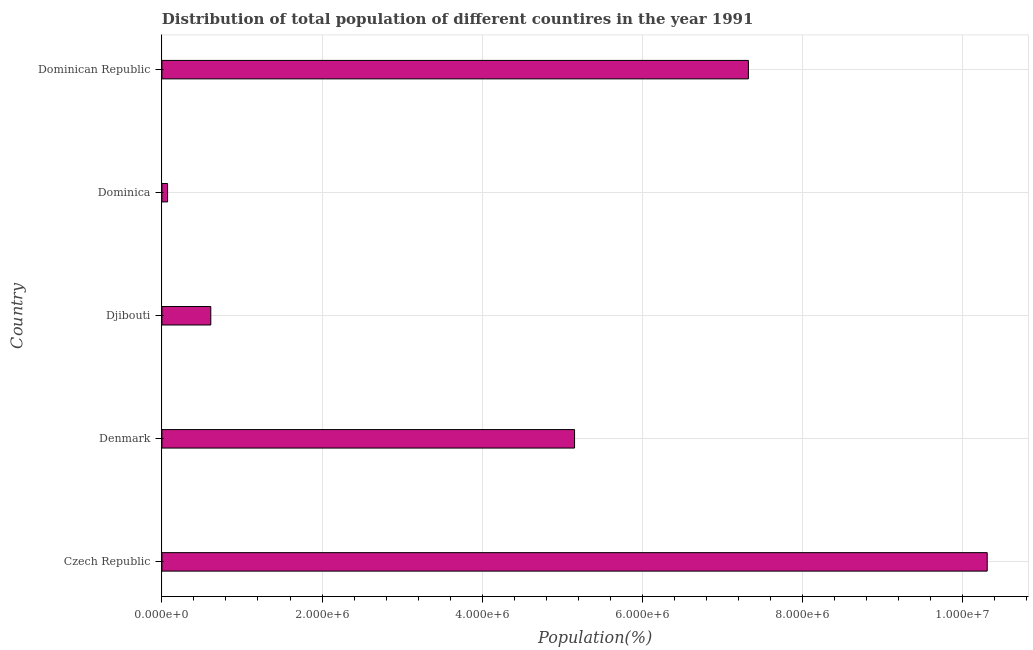Does the graph contain any zero values?
Your answer should be very brief. No. Does the graph contain grids?
Provide a short and direct response. Yes. What is the title of the graph?
Your answer should be very brief. Distribution of total population of different countires in the year 1991. What is the label or title of the X-axis?
Provide a succinct answer. Population(%). What is the population in Dominica?
Give a very brief answer. 7.08e+04. Across all countries, what is the maximum population?
Keep it short and to the point. 1.03e+07. Across all countries, what is the minimum population?
Your response must be concise. 7.08e+04. In which country was the population maximum?
Your answer should be compact. Czech Republic. In which country was the population minimum?
Provide a short and direct response. Dominica. What is the sum of the population?
Offer a terse response. 2.35e+07. What is the difference between the population in Denmark and Dominica?
Keep it short and to the point. 5.08e+06. What is the average population per country?
Ensure brevity in your answer.  4.69e+06. What is the median population?
Keep it short and to the point. 5.15e+06. In how many countries, is the population greater than 400000 %?
Your answer should be compact. 4. What is the ratio of the population in Czech Republic to that in Dominican Republic?
Your answer should be compact. 1.41. Is the population in Djibouti less than that in Dominican Republic?
Ensure brevity in your answer.  Yes. Is the difference between the population in Denmark and Dominican Republic greater than the difference between any two countries?
Offer a very short reply. No. What is the difference between the highest and the second highest population?
Keep it short and to the point. 2.98e+06. Is the sum of the population in Czech Republic and Denmark greater than the maximum population across all countries?
Keep it short and to the point. Yes. What is the difference between the highest and the lowest population?
Your answer should be compact. 1.02e+07. Are all the bars in the graph horizontal?
Your answer should be compact. Yes. What is the difference between two consecutive major ticks on the X-axis?
Your answer should be compact. 2.00e+06. Are the values on the major ticks of X-axis written in scientific E-notation?
Your response must be concise. Yes. What is the Population(%) in Czech Republic?
Your answer should be very brief. 1.03e+07. What is the Population(%) in Denmark?
Keep it short and to the point. 5.15e+06. What is the Population(%) in Djibouti?
Ensure brevity in your answer.  6.11e+05. What is the Population(%) in Dominica?
Offer a terse response. 7.08e+04. What is the Population(%) in Dominican Republic?
Give a very brief answer. 7.33e+06. What is the difference between the Population(%) in Czech Republic and Denmark?
Give a very brief answer. 5.15e+06. What is the difference between the Population(%) in Czech Republic and Djibouti?
Make the answer very short. 9.70e+06. What is the difference between the Population(%) in Czech Republic and Dominica?
Ensure brevity in your answer.  1.02e+07. What is the difference between the Population(%) in Czech Republic and Dominican Republic?
Provide a succinct answer. 2.98e+06. What is the difference between the Population(%) in Denmark and Djibouti?
Offer a terse response. 4.54e+06. What is the difference between the Population(%) in Denmark and Dominica?
Your response must be concise. 5.08e+06. What is the difference between the Population(%) in Denmark and Dominican Republic?
Provide a short and direct response. -2.17e+06. What is the difference between the Population(%) in Djibouti and Dominica?
Offer a terse response. 5.40e+05. What is the difference between the Population(%) in Djibouti and Dominican Republic?
Provide a succinct answer. -6.71e+06. What is the difference between the Population(%) in Dominica and Dominican Republic?
Provide a short and direct response. -7.25e+06. What is the ratio of the Population(%) in Czech Republic to that in Denmark?
Provide a short and direct response. 2. What is the ratio of the Population(%) in Czech Republic to that in Djibouti?
Offer a very short reply. 16.88. What is the ratio of the Population(%) in Czech Republic to that in Dominica?
Offer a very short reply. 145.5. What is the ratio of the Population(%) in Czech Republic to that in Dominican Republic?
Keep it short and to the point. 1.41. What is the ratio of the Population(%) in Denmark to that in Djibouti?
Offer a very short reply. 8.44. What is the ratio of the Population(%) in Denmark to that in Dominica?
Provide a succinct answer. 72.75. What is the ratio of the Population(%) in Denmark to that in Dominican Republic?
Keep it short and to the point. 0.7. What is the ratio of the Population(%) in Djibouti to that in Dominica?
Keep it short and to the point. 8.62. What is the ratio of the Population(%) in Djibouti to that in Dominican Republic?
Provide a short and direct response. 0.08. 